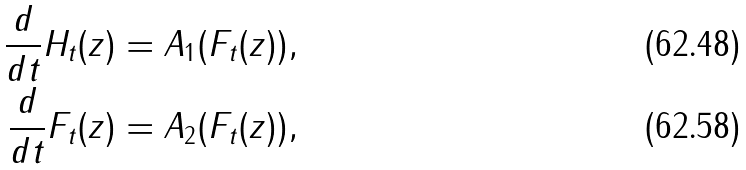<formula> <loc_0><loc_0><loc_500><loc_500>\frac { d } { d t } H _ { t } ( z ) = A _ { 1 } ( F _ { t } ( z ) ) , \\ \frac { d } { d t } F _ { t } ( z ) = A _ { 2 } ( F _ { t } ( z ) ) ,</formula> 